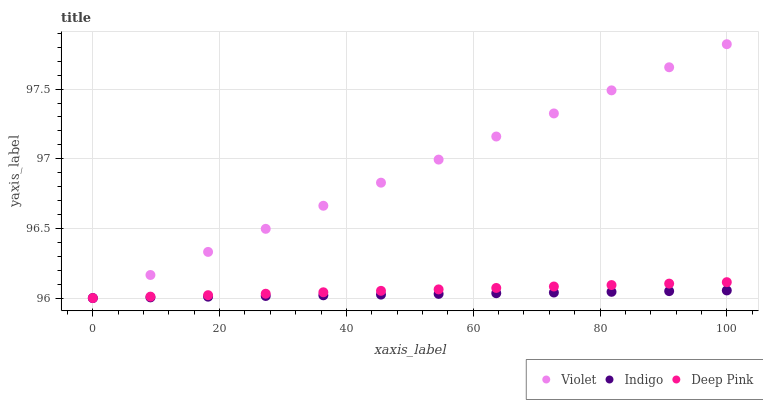Does Indigo have the minimum area under the curve?
Answer yes or no. Yes. Does Violet have the maximum area under the curve?
Answer yes or no. Yes. Does Violet have the minimum area under the curve?
Answer yes or no. No. Does Indigo have the maximum area under the curve?
Answer yes or no. No. Is Indigo the smoothest?
Answer yes or no. Yes. Is Violet the roughest?
Answer yes or no. Yes. Is Violet the smoothest?
Answer yes or no. No. Is Indigo the roughest?
Answer yes or no. No. Does Deep Pink have the lowest value?
Answer yes or no. Yes. Does Violet have the highest value?
Answer yes or no. Yes. Does Indigo have the highest value?
Answer yes or no. No. Does Deep Pink intersect Violet?
Answer yes or no. Yes. Is Deep Pink less than Violet?
Answer yes or no. No. Is Deep Pink greater than Violet?
Answer yes or no. No. 